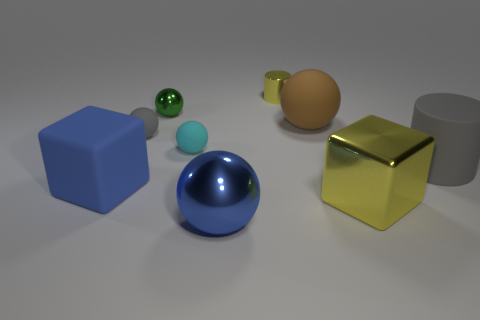Subtract all brown balls. Subtract all brown blocks. How many balls are left? 4 Add 1 cyan rubber balls. How many objects exist? 10 Subtract all blocks. How many objects are left? 7 Add 6 tiny blue metal cubes. How many tiny blue metal cubes exist? 6 Subtract 1 yellow cylinders. How many objects are left? 8 Subtract all gray matte objects. Subtract all purple shiny balls. How many objects are left? 7 Add 7 cyan matte balls. How many cyan matte balls are left? 8 